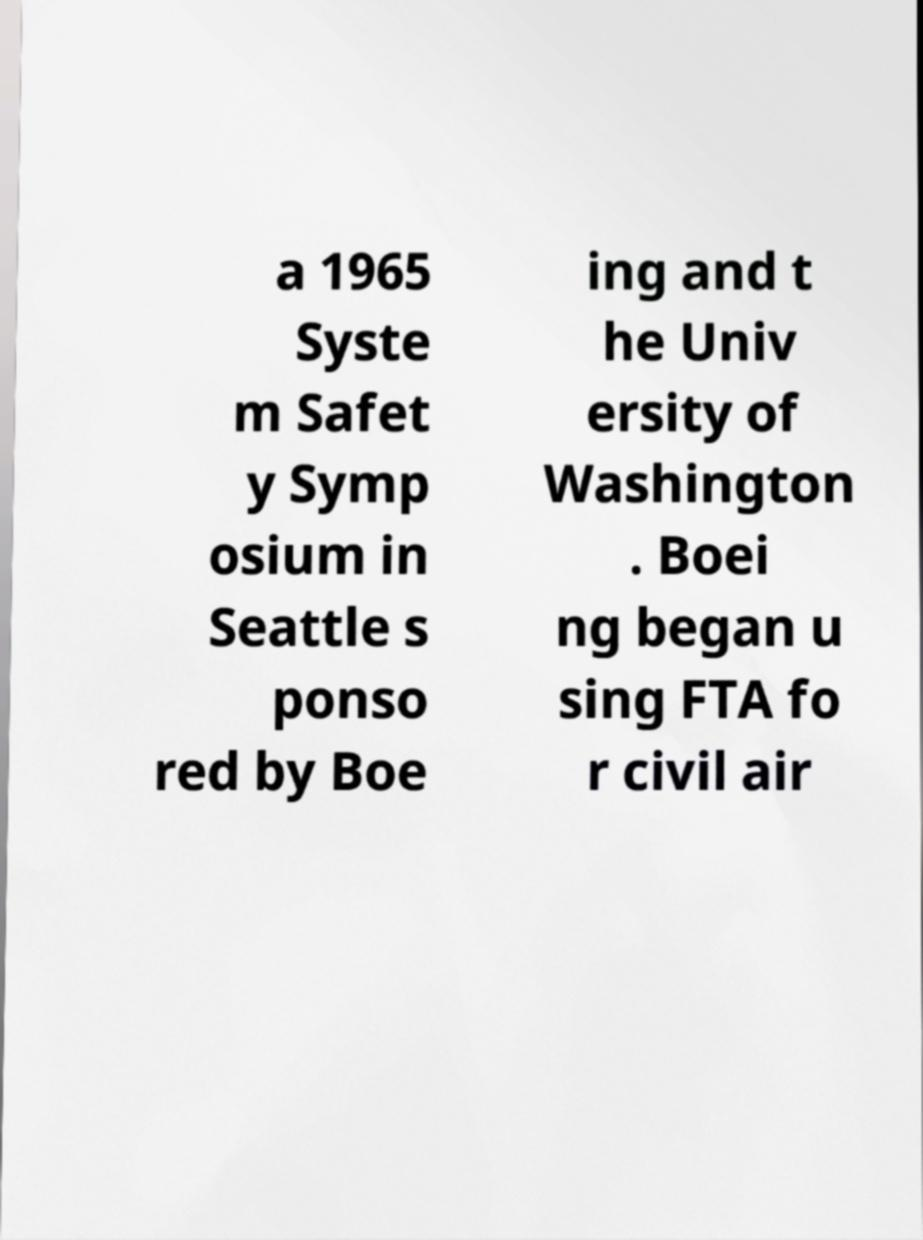What messages or text are displayed in this image? I need them in a readable, typed format. a 1965 Syste m Safet y Symp osium in Seattle s ponso red by Boe ing and t he Univ ersity of Washington . Boei ng began u sing FTA fo r civil air 